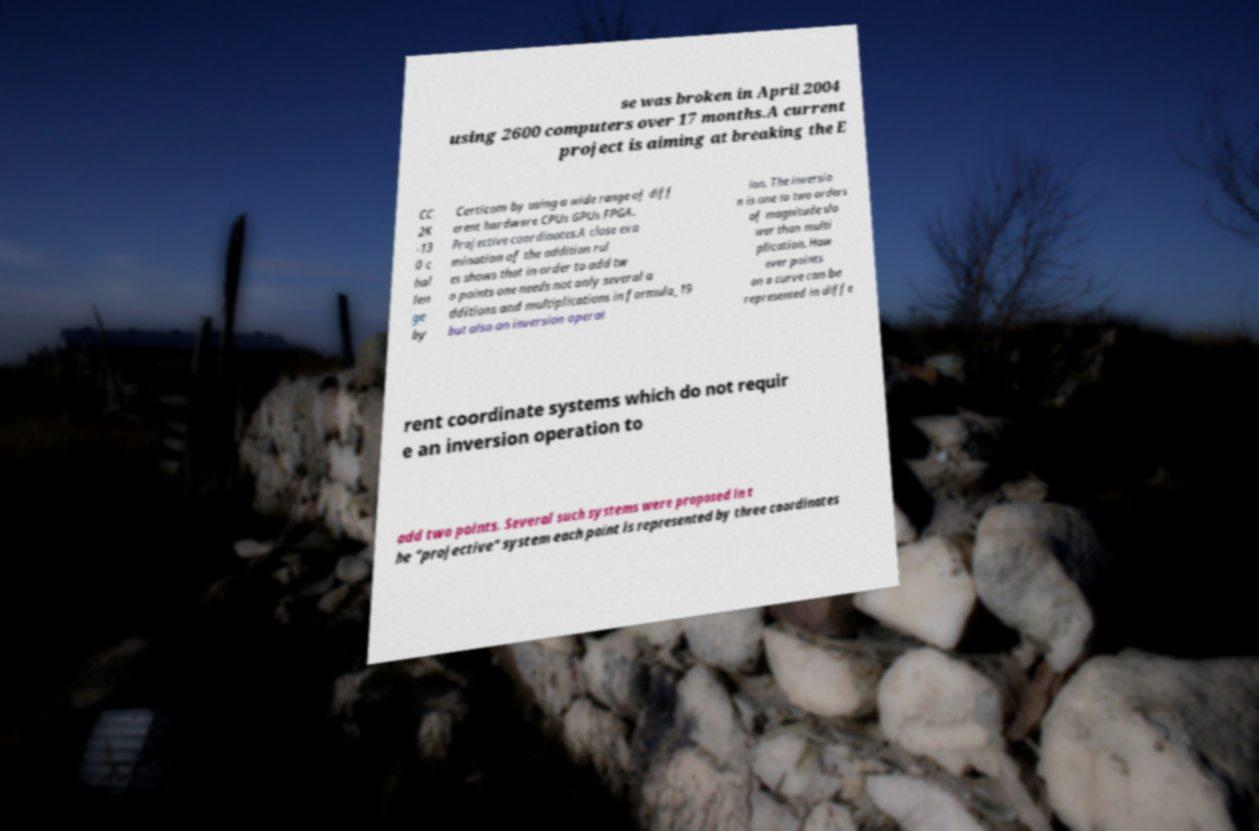What messages or text are displayed in this image? I need them in a readable, typed format. se was broken in April 2004 using 2600 computers over 17 months.A current project is aiming at breaking the E CC 2K -13 0 c hal len ge by Certicom by using a wide range of diff erent hardware CPUs GPUs FPGA. Projective coordinates.A close exa mination of the addition rul es shows that in order to add tw o points one needs not only several a dditions and multiplications in formula_19 but also an inversion operat ion. The inversio n is one to two orders of magnitude slo wer than multi plication. How ever points on a curve can be represented in diffe rent coordinate systems which do not requir e an inversion operation to add two points. Several such systems were proposed in t he "projective" system each point is represented by three coordinates 